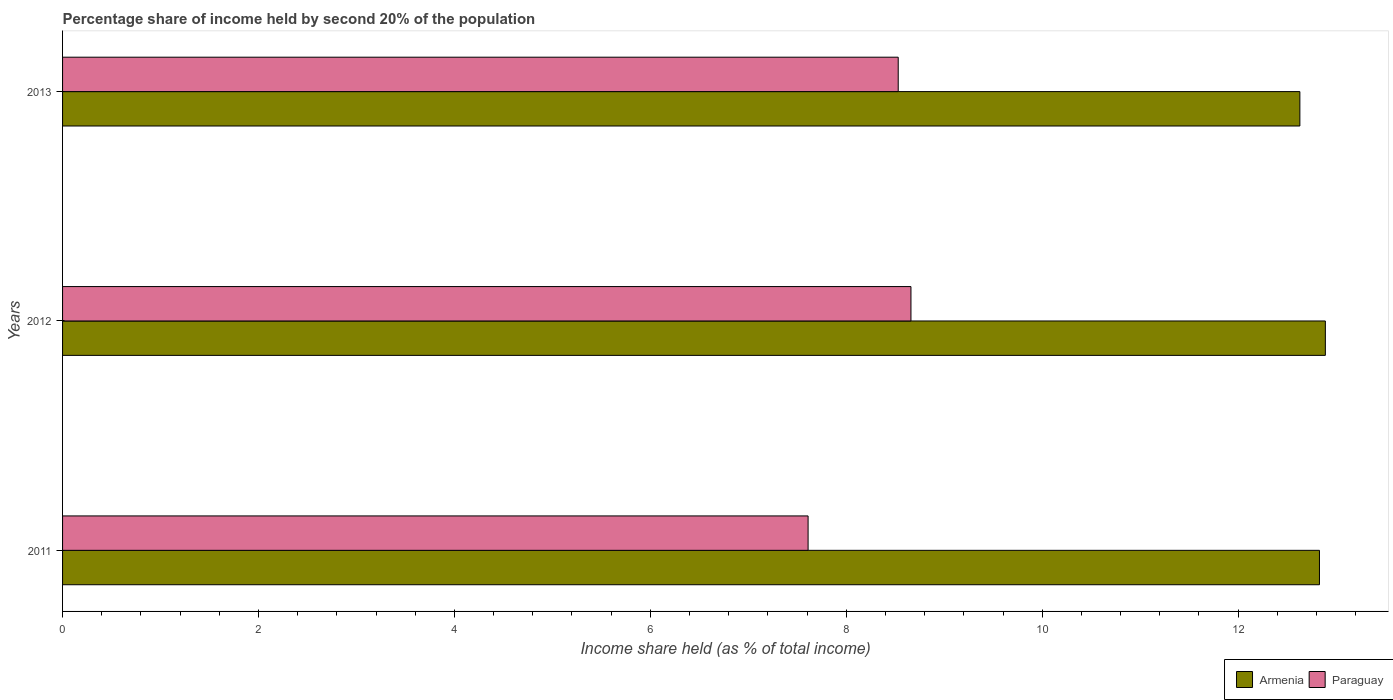How many different coloured bars are there?
Give a very brief answer. 2. Are the number of bars per tick equal to the number of legend labels?
Keep it short and to the point. Yes. How many bars are there on the 1st tick from the top?
Make the answer very short. 2. How many bars are there on the 1st tick from the bottom?
Provide a succinct answer. 2. What is the label of the 2nd group of bars from the top?
Provide a short and direct response. 2012. In how many cases, is the number of bars for a given year not equal to the number of legend labels?
Give a very brief answer. 0. What is the share of income held by second 20% of the population in Armenia in 2012?
Give a very brief answer. 12.89. Across all years, what is the maximum share of income held by second 20% of the population in Armenia?
Provide a succinct answer. 12.89. Across all years, what is the minimum share of income held by second 20% of the population in Armenia?
Offer a terse response. 12.63. In which year was the share of income held by second 20% of the population in Armenia maximum?
Provide a succinct answer. 2012. In which year was the share of income held by second 20% of the population in Paraguay minimum?
Your response must be concise. 2011. What is the total share of income held by second 20% of the population in Armenia in the graph?
Keep it short and to the point. 38.35. What is the difference between the share of income held by second 20% of the population in Armenia in 2012 and that in 2013?
Provide a succinct answer. 0.26. What is the difference between the share of income held by second 20% of the population in Armenia in 2011 and the share of income held by second 20% of the population in Paraguay in 2013?
Make the answer very short. 4.3. What is the average share of income held by second 20% of the population in Paraguay per year?
Make the answer very short. 8.27. In the year 2011, what is the difference between the share of income held by second 20% of the population in Paraguay and share of income held by second 20% of the population in Armenia?
Your answer should be compact. -5.22. In how many years, is the share of income held by second 20% of the population in Paraguay greater than 8 %?
Your answer should be very brief. 2. What is the ratio of the share of income held by second 20% of the population in Paraguay in 2012 to that in 2013?
Your answer should be compact. 1.02. Is the share of income held by second 20% of the population in Paraguay in 2012 less than that in 2013?
Offer a very short reply. No. What is the difference between the highest and the second highest share of income held by second 20% of the population in Paraguay?
Ensure brevity in your answer.  0.13. What is the difference between the highest and the lowest share of income held by second 20% of the population in Paraguay?
Your response must be concise. 1.05. In how many years, is the share of income held by second 20% of the population in Armenia greater than the average share of income held by second 20% of the population in Armenia taken over all years?
Give a very brief answer. 2. Is the sum of the share of income held by second 20% of the population in Armenia in 2011 and 2012 greater than the maximum share of income held by second 20% of the population in Paraguay across all years?
Offer a very short reply. Yes. What does the 1st bar from the top in 2011 represents?
Keep it short and to the point. Paraguay. What does the 2nd bar from the bottom in 2012 represents?
Your answer should be compact. Paraguay. How many years are there in the graph?
Provide a succinct answer. 3. Does the graph contain grids?
Keep it short and to the point. No. What is the title of the graph?
Provide a succinct answer. Percentage share of income held by second 20% of the population. Does "Nicaragua" appear as one of the legend labels in the graph?
Ensure brevity in your answer.  No. What is the label or title of the X-axis?
Your answer should be compact. Income share held (as % of total income). What is the Income share held (as % of total income) of Armenia in 2011?
Provide a succinct answer. 12.83. What is the Income share held (as % of total income) of Paraguay in 2011?
Offer a very short reply. 7.61. What is the Income share held (as % of total income) of Armenia in 2012?
Offer a very short reply. 12.89. What is the Income share held (as % of total income) in Paraguay in 2012?
Keep it short and to the point. 8.66. What is the Income share held (as % of total income) of Armenia in 2013?
Offer a very short reply. 12.63. What is the Income share held (as % of total income) in Paraguay in 2013?
Provide a succinct answer. 8.53. Across all years, what is the maximum Income share held (as % of total income) in Armenia?
Offer a terse response. 12.89. Across all years, what is the maximum Income share held (as % of total income) of Paraguay?
Your answer should be compact. 8.66. Across all years, what is the minimum Income share held (as % of total income) in Armenia?
Your answer should be compact. 12.63. Across all years, what is the minimum Income share held (as % of total income) of Paraguay?
Offer a terse response. 7.61. What is the total Income share held (as % of total income) of Armenia in the graph?
Keep it short and to the point. 38.35. What is the total Income share held (as % of total income) of Paraguay in the graph?
Your answer should be compact. 24.8. What is the difference between the Income share held (as % of total income) in Armenia in 2011 and that in 2012?
Ensure brevity in your answer.  -0.06. What is the difference between the Income share held (as % of total income) in Paraguay in 2011 and that in 2012?
Give a very brief answer. -1.05. What is the difference between the Income share held (as % of total income) of Armenia in 2011 and that in 2013?
Offer a terse response. 0.2. What is the difference between the Income share held (as % of total income) in Paraguay in 2011 and that in 2013?
Give a very brief answer. -0.92. What is the difference between the Income share held (as % of total income) of Armenia in 2012 and that in 2013?
Make the answer very short. 0.26. What is the difference between the Income share held (as % of total income) of Paraguay in 2012 and that in 2013?
Your answer should be compact. 0.13. What is the difference between the Income share held (as % of total income) of Armenia in 2011 and the Income share held (as % of total income) of Paraguay in 2012?
Provide a succinct answer. 4.17. What is the difference between the Income share held (as % of total income) of Armenia in 2012 and the Income share held (as % of total income) of Paraguay in 2013?
Make the answer very short. 4.36. What is the average Income share held (as % of total income) of Armenia per year?
Keep it short and to the point. 12.78. What is the average Income share held (as % of total income) in Paraguay per year?
Your answer should be compact. 8.27. In the year 2011, what is the difference between the Income share held (as % of total income) of Armenia and Income share held (as % of total income) of Paraguay?
Offer a terse response. 5.22. In the year 2012, what is the difference between the Income share held (as % of total income) of Armenia and Income share held (as % of total income) of Paraguay?
Ensure brevity in your answer.  4.23. In the year 2013, what is the difference between the Income share held (as % of total income) of Armenia and Income share held (as % of total income) of Paraguay?
Provide a succinct answer. 4.1. What is the ratio of the Income share held (as % of total income) of Paraguay in 2011 to that in 2012?
Give a very brief answer. 0.88. What is the ratio of the Income share held (as % of total income) in Armenia in 2011 to that in 2013?
Make the answer very short. 1.02. What is the ratio of the Income share held (as % of total income) in Paraguay in 2011 to that in 2013?
Offer a terse response. 0.89. What is the ratio of the Income share held (as % of total income) of Armenia in 2012 to that in 2013?
Offer a terse response. 1.02. What is the ratio of the Income share held (as % of total income) of Paraguay in 2012 to that in 2013?
Provide a succinct answer. 1.02. What is the difference between the highest and the second highest Income share held (as % of total income) of Armenia?
Ensure brevity in your answer.  0.06. What is the difference between the highest and the second highest Income share held (as % of total income) of Paraguay?
Your answer should be very brief. 0.13. What is the difference between the highest and the lowest Income share held (as % of total income) of Armenia?
Give a very brief answer. 0.26. What is the difference between the highest and the lowest Income share held (as % of total income) of Paraguay?
Your response must be concise. 1.05. 